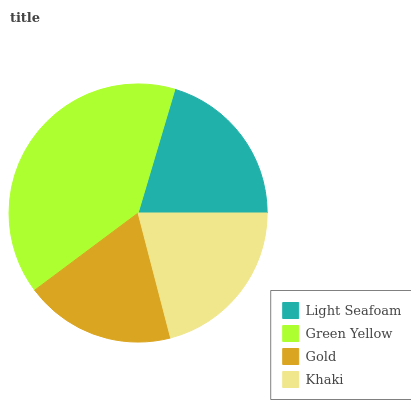Is Gold the minimum?
Answer yes or no. Yes. Is Green Yellow the maximum?
Answer yes or no. Yes. Is Green Yellow the minimum?
Answer yes or no. No. Is Gold the maximum?
Answer yes or no. No. Is Green Yellow greater than Gold?
Answer yes or no. Yes. Is Gold less than Green Yellow?
Answer yes or no. Yes. Is Gold greater than Green Yellow?
Answer yes or no. No. Is Green Yellow less than Gold?
Answer yes or no. No. Is Khaki the high median?
Answer yes or no. Yes. Is Light Seafoam the low median?
Answer yes or no. Yes. Is Green Yellow the high median?
Answer yes or no. No. Is Green Yellow the low median?
Answer yes or no. No. 